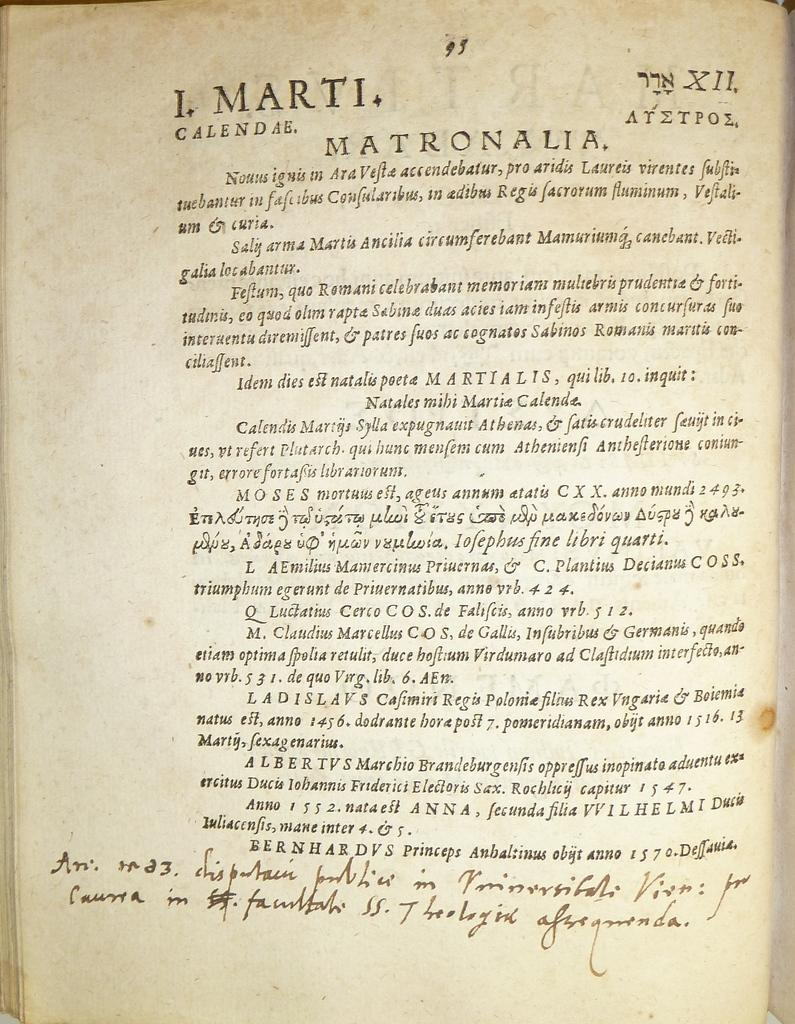<image>
Offer a succinct explanation of the picture presented. A page of text that has foreign writing on it. 